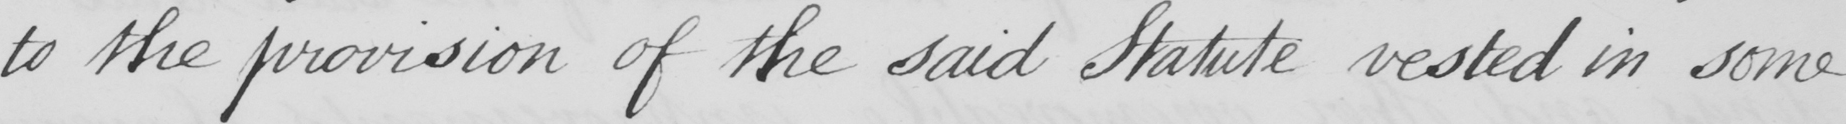Can you read and transcribe this handwriting? to the provision of the said Statute vested in some 